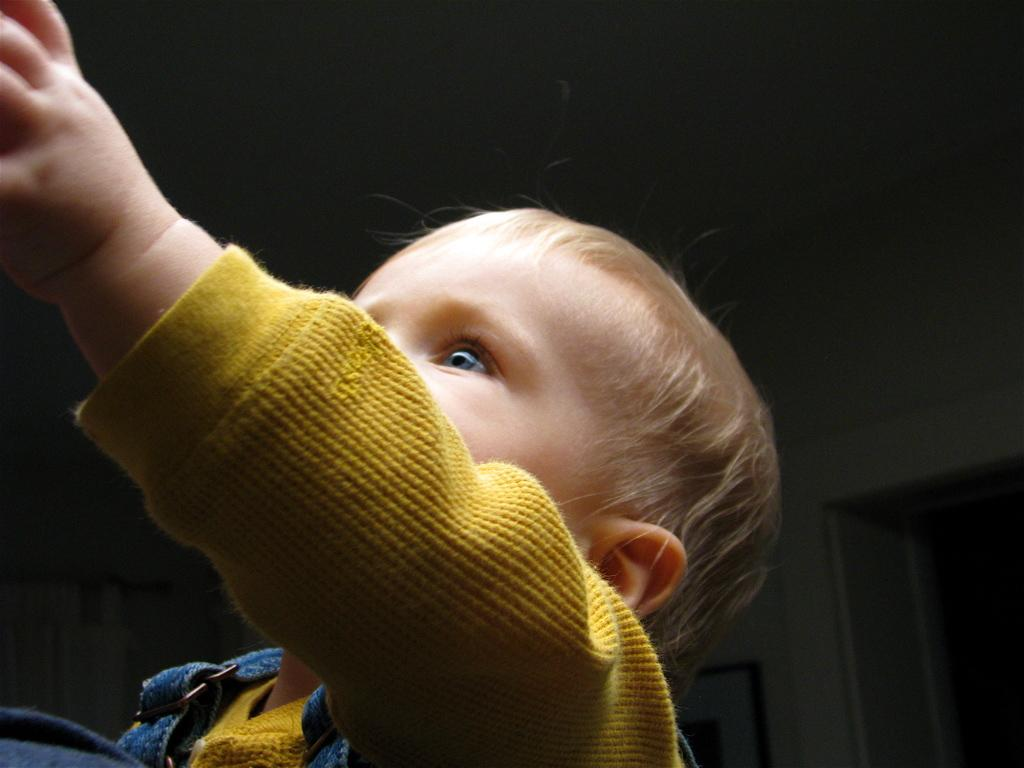What is the main subject of the image? The main subject of the image is a baby. What can be observed about the baby's attire? The baby is wearing clothes. Can you describe the background of the image? The background of the image is pale black. What type of baseball equipment can be seen in the image? There is no baseball equipment present in the image; it features a baby wearing clothes against a pale black background. What kind of reward is the baby holding in the image? There is no reward visible in the image; it only shows a baby wearing clothes against a pale black background. 